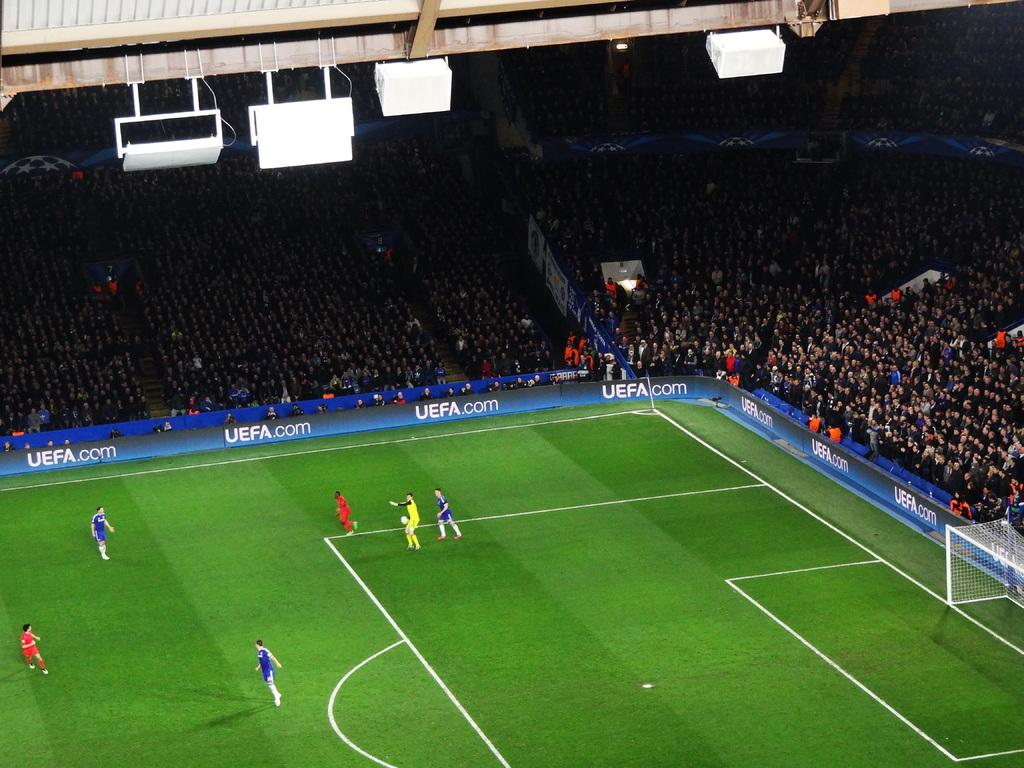<image>
Render a clear and concise summary of the photo. Soccer Stadium affiliated with UEFA.com as its sponsor. 